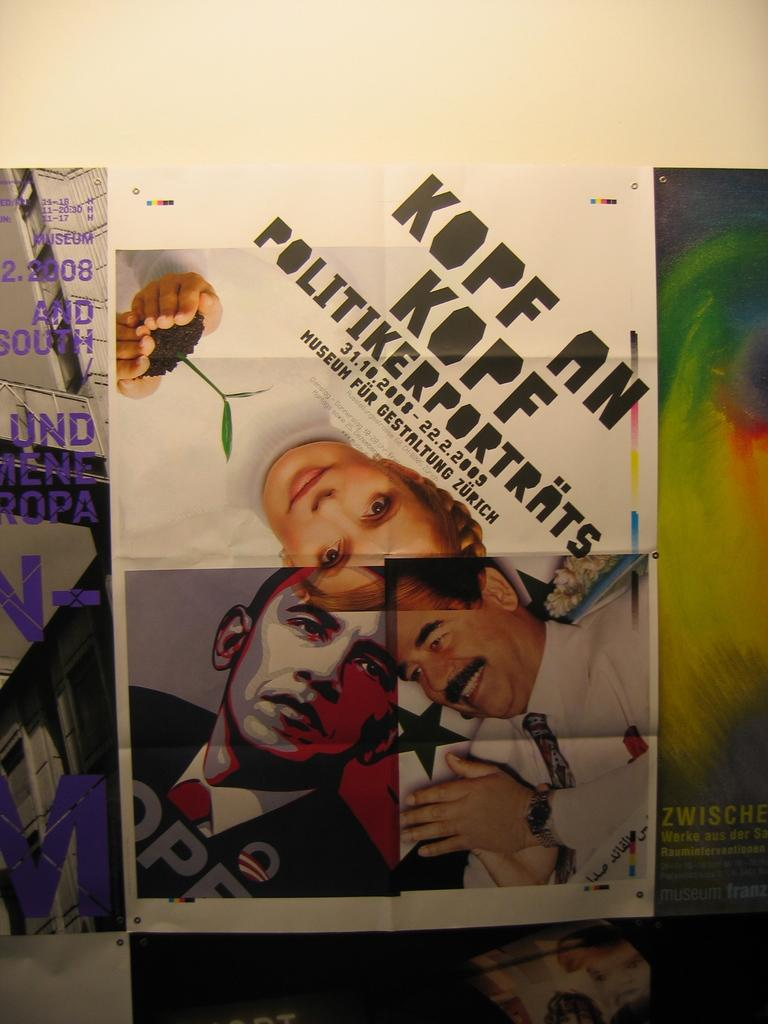What is present in the image that contains information or a message? There is a poster in the image that contains information or a message. What type of content is on the poster? The poster contains text and images of persons. What type of corn is being used to cover the poster in the image? There is no corn present in the image, and the poster is not being covered by anything. 